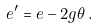<formula> <loc_0><loc_0><loc_500><loc_500>e ^ { \prime } = e - 2 g \theta \, .</formula> 